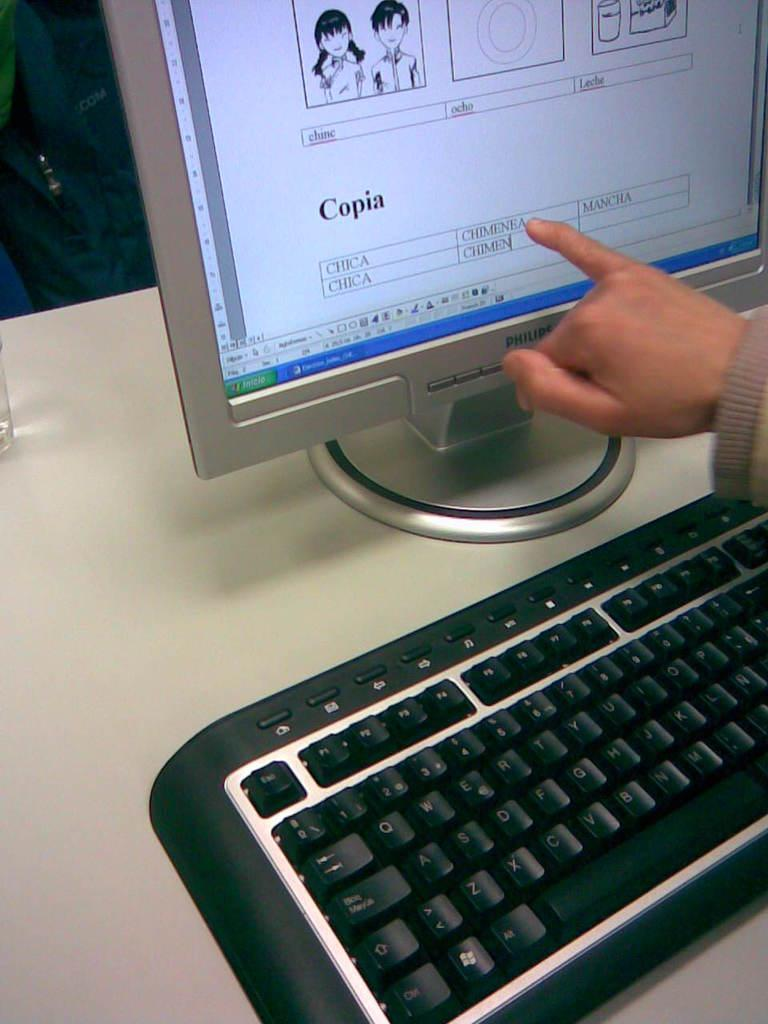Provide a one-sentence caption for the provided image. A person pointing at the word Chimenea on a computer screen. 